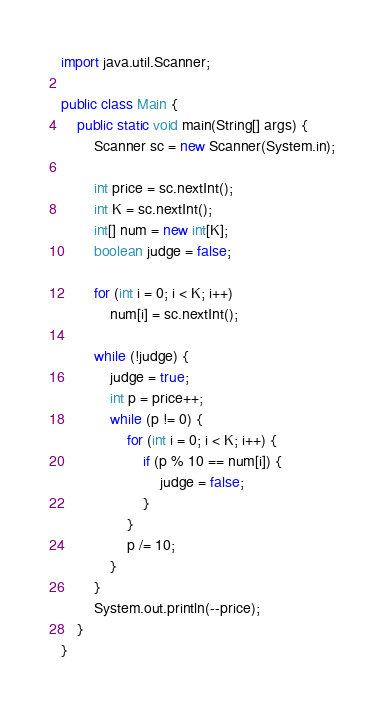Convert code to text. <code><loc_0><loc_0><loc_500><loc_500><_Java_>import java.util.Scanner;

public class Main {
	public static void main(String[] args) {
		Scanner sc = new Scanner(System.in);

		int price = sc.nextInt();
		int K = sc.nextInt();
		int[] num = new int[K];
		boolean judge = false;

		for (int i = 0; i < K; i++)
			num[i] = sc.nextInt();

		while (!judge) {
			judge = true;
			int p = price++;
			while (p != 0) {
				for (int i = 0; i < K; i++) {
					if (p % 10 == num[i]) {
						judge = false;
					}
				}
				p /= 10;
			}
		}
		System.out.println(--price);
	}
}</code> 